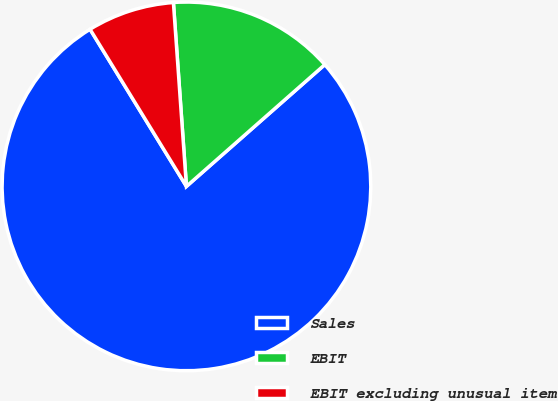<chart> <loc_0><loc_0><loc_500><loc_500><pie_chart><fcel>Sales<fcel>EBIT<fcel>EBIT excluding unusual item<nl><fcel>77.73%<fcel>14.64%<fcel>7.63%<nl></chart> 